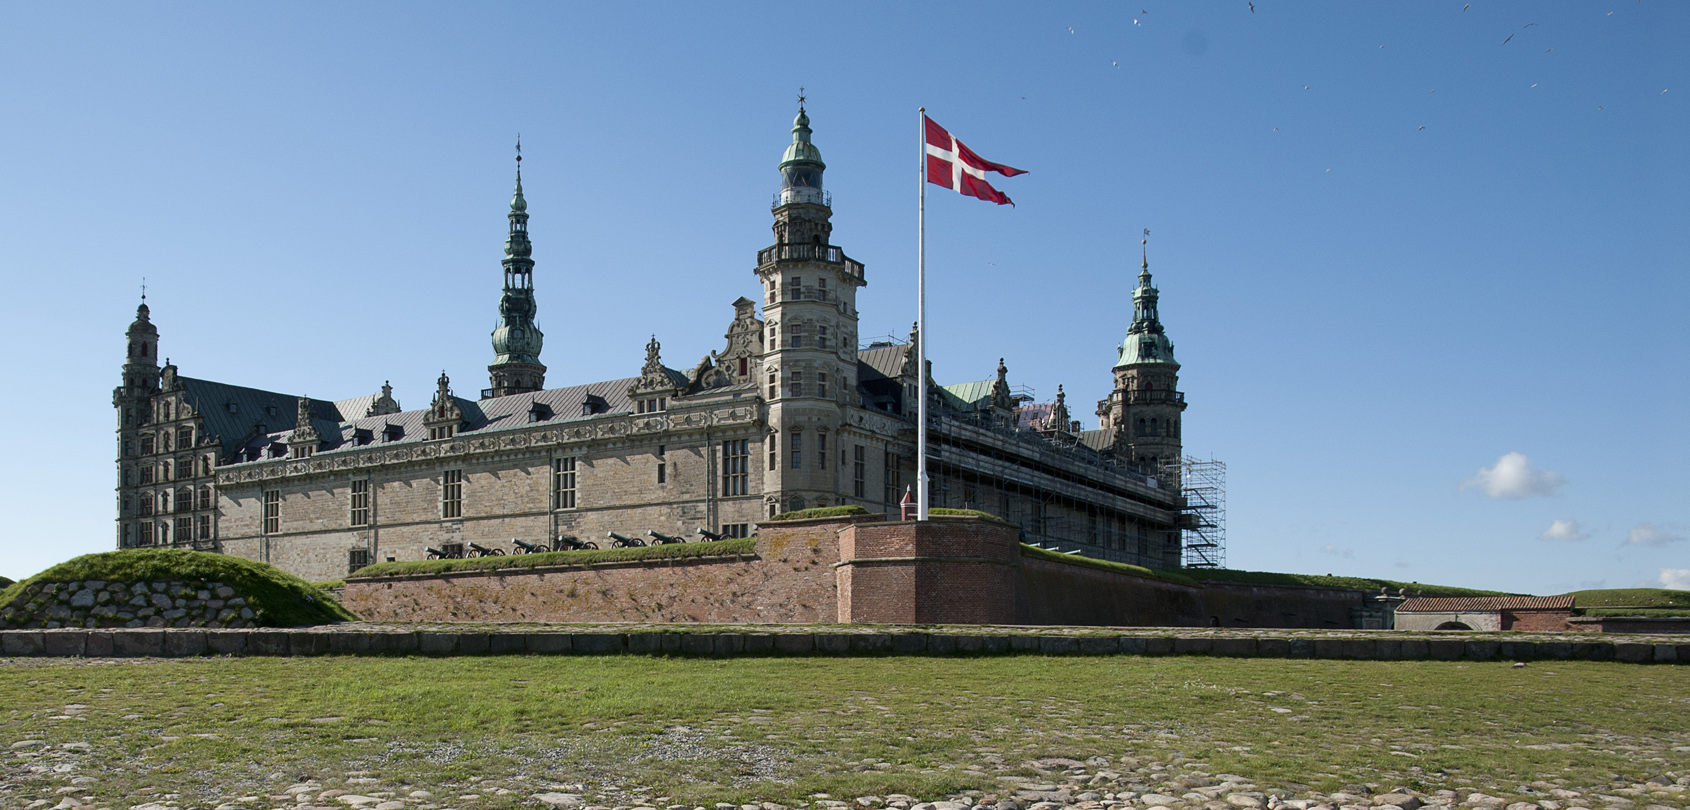Can you tell me more about the history of this castle? Kronborg Castle, also known as Elsinore, is a 16th-century castle in Helsingør, Denmark, famous for being the setting of Shakespeare's play 'Hamlet'. Built in 1574 by King Frederick II, it was a strategic fortification for controlling the passage between the North Sea and the Baltic Sea through the Oresund Strait. Over the centuries, it has served various roles, including a royal residence, a military stronghold, and even a prison. Today, it is a UNESCO World Heritage Site, attracting visitors from around the world with its rich history and architectural splendor. What is the significance of the Danish flag flying in front of the castle? The Danish flag, known as the Dannebrog, is one of the oldest national flags in the world. It symbolizes Denmark's heritage, independence, and national pride. Its presence in front of Kronborg Castle signifies the castle's importance as a national monument and cultural icon, reflecting Denmark's historical and architectural heritage. Flying the flag here highlights the connection between the country's past and its present, celebrating national unity and pride. 